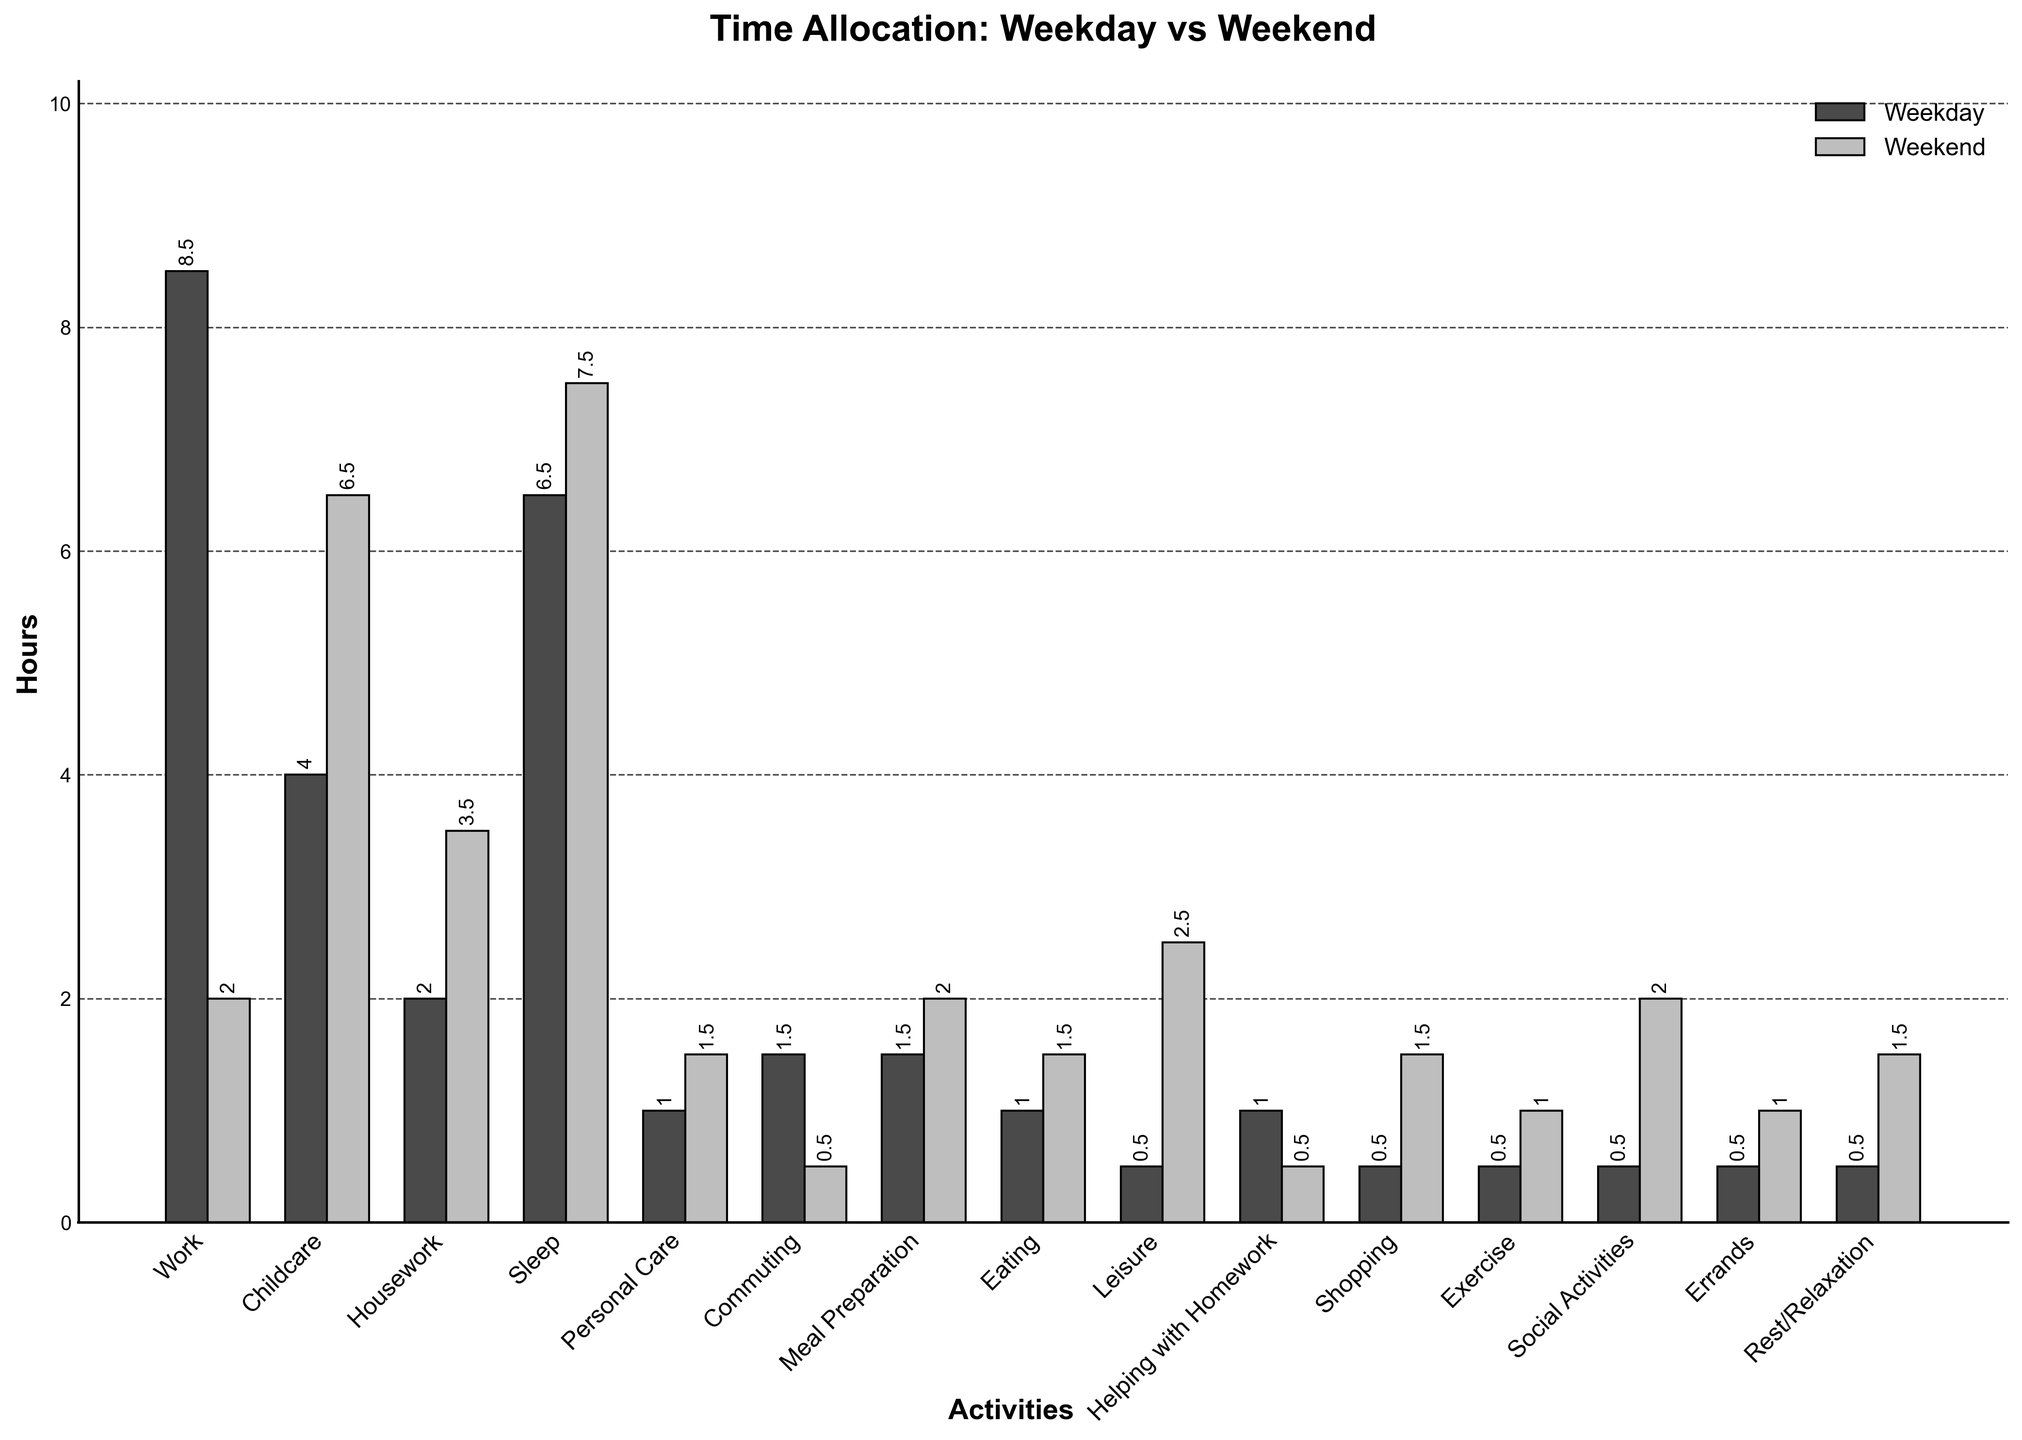On which activity do single parents spend more hours during weekends compared to weekdays? For each activity, compare the hours spent on weekends versus weekdays. If the weekend hours are higher, note that activity. Leisure shows an increase from \(0.5\) hours to \(2.5\) hours on weekends.
Answer: Leisure What is the total time spent on housework, meal preparation, and eating during a weekday? Sum the hours spent on housework, meal preparation, and eating on a weekday: \(2.0 + 1.5 + 1.0 = 4.5\) hours.
Answer: 4.5 hours Which activities have equal or nearly equal time allocation on both weekdays and weekends? Check the time for each activity on weekdays and weekends and find those with minimal differences. Personal Care and Helping with Homework have small differences \(0.5\) and \(0.5\) respectively.
Answer: Personal Care, Helping with Homework How much more time is spent on leisure activities during weekends compared to weekdays? Subtract the hours spent on leisure during weekdays from those during weekends: \(2.5 - 0.5 = 2.0\) hours.
Answer: 2.0 hours What is the average time spent on commuting, shopping, and errands during weekdays and weekends? Sum the hours allocated to Commuting, Shopping, and Errands, then divide by the number of activities: \[\left(1.5 + 0.5 + 0.5\right) / 3 = 2.5 / 3 = 0.83\ \text{hours (weekday),}\]\[\left( 0.5 + 1.5 + 1.0\right) / 3 = 3.0 / 3 = 1.0\ \text{hours (weekend)}\]
Answer: 0.83 hours, 1.0 hours Which category shows the highest increase in hours on weekends compared to weekdays? Calculate the difference in hours between weekends and weekdays for each activity. Childcare shows a significant increase of \(6.5 - 4.0 = 2.5\) hours.
Answer: Childcare What is the combined time spent on social activities and rest/relaxation during a weekend? Add the hours spent on social activities and rest/relaxation during weekends: \(2.0 + 1.5 = 3.5\) hours.
Answer: 3.5 hours 